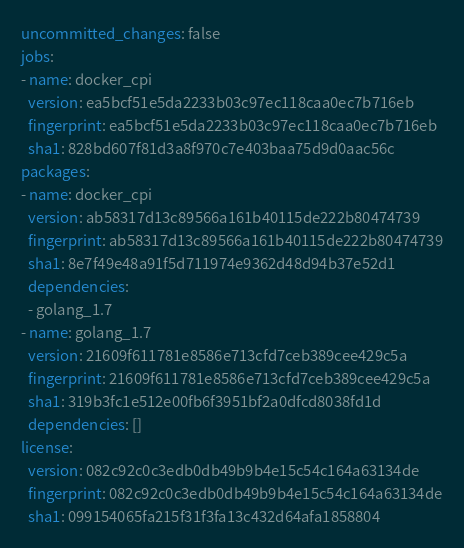<code> <loc_0><loc_0><loc_500><loc_500><_YAML_>uncommitted_changes: false
jobs:
- name: docker_cpi
  version: ea5bcf51e5da2233b03c97ec118caa0ec7b716eb
  fingerprint: ea5bcf51e5da2233b03c97ec118caa0ec7b716eb
  sha1: 828bd607f81d3a8f970c7e403baa75d9d0aac56c
packages:
- name: docker_cpi
  version: ab58317d13c89566a161b40115de222b80474739
  fingerprint: ab58317d13c89566a161b40115de222b80474739
  sha1: 8e7f49e48a91f5d711974e9362d48d94b37e52d1
  dependencies:
  - golang_1.7
- name: golang_1.7
  version: 21609f611781e8586e713cfd7ceb389cee429c5a
  fingerprint: 21609f611781e8586e713cfd7ceb389cee429c5a
  sha1: 319b3fc1e512e00fb6f3951bf2a0dfcd8038fd1d
  dependencies: []
license:
  version: 082c92c0c3edb0db49b9b4e15c54c164a63134de
  fingerprint: 082c92c0c3edb0db49b9b4e15c54c164a63134de
  sha1: 099154065fa215f31f3fa13c432d64afa1858804
</code> 